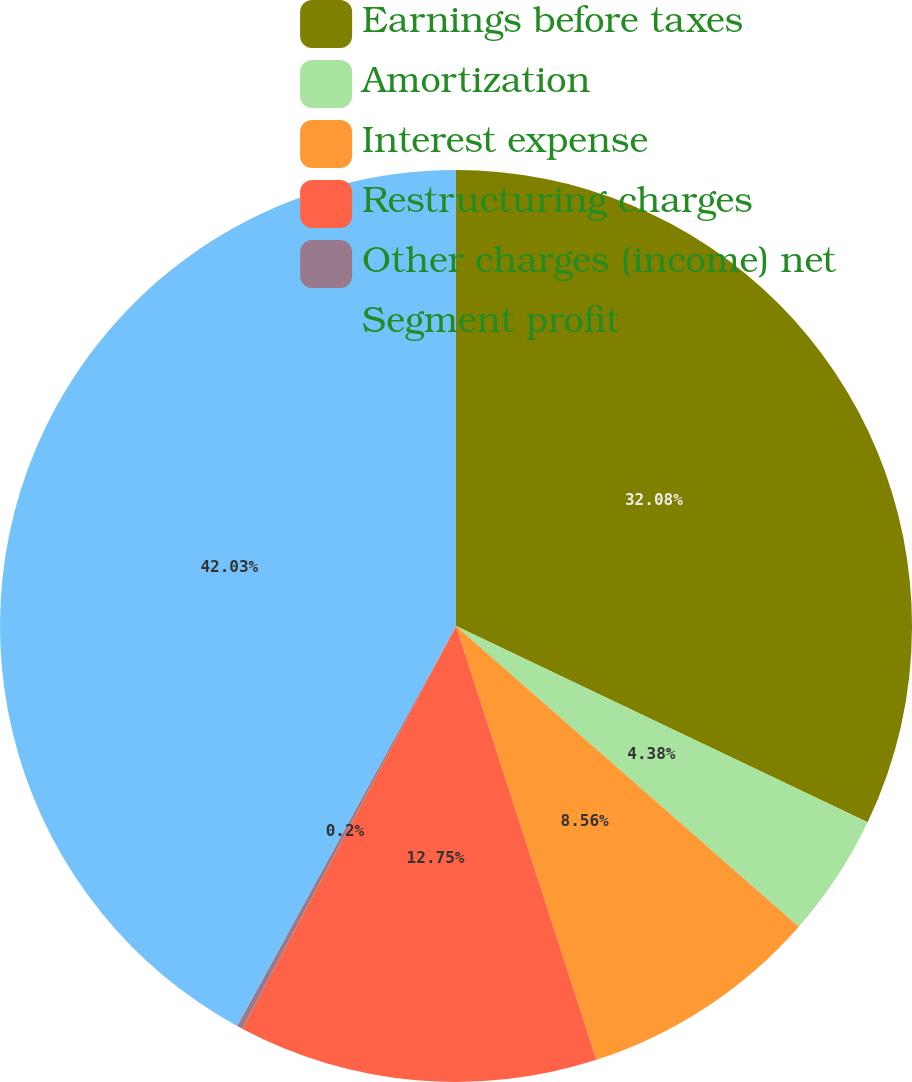<chart> <loc_0><loc_0><loc_500><loc_500><pie_chart><fcel>Earnings before taxes<fcel>Amortization<fcel>Interest expense<fcel>Restructuring charges<fcel>Other charges (income) net<fcel>Segment profit<nl><fcel>32.08%<fcel>4.38%<fcel>8.56%<fcel>12.75%<fcel>0.2%<fcel>42.03%<nl></chart> 